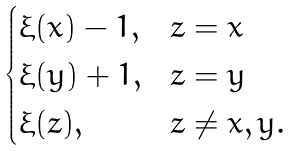Convert formula to latex. <formula><loc_0><loc_0><loc_500><loc_500>\begin{cases} \xi ( x ) - 1 , & z = x \\ \xi ( y ) + 1 , & z = y \\ \xi ( z ) , & z \neq x , y . \\ \end{cases}</formula> 